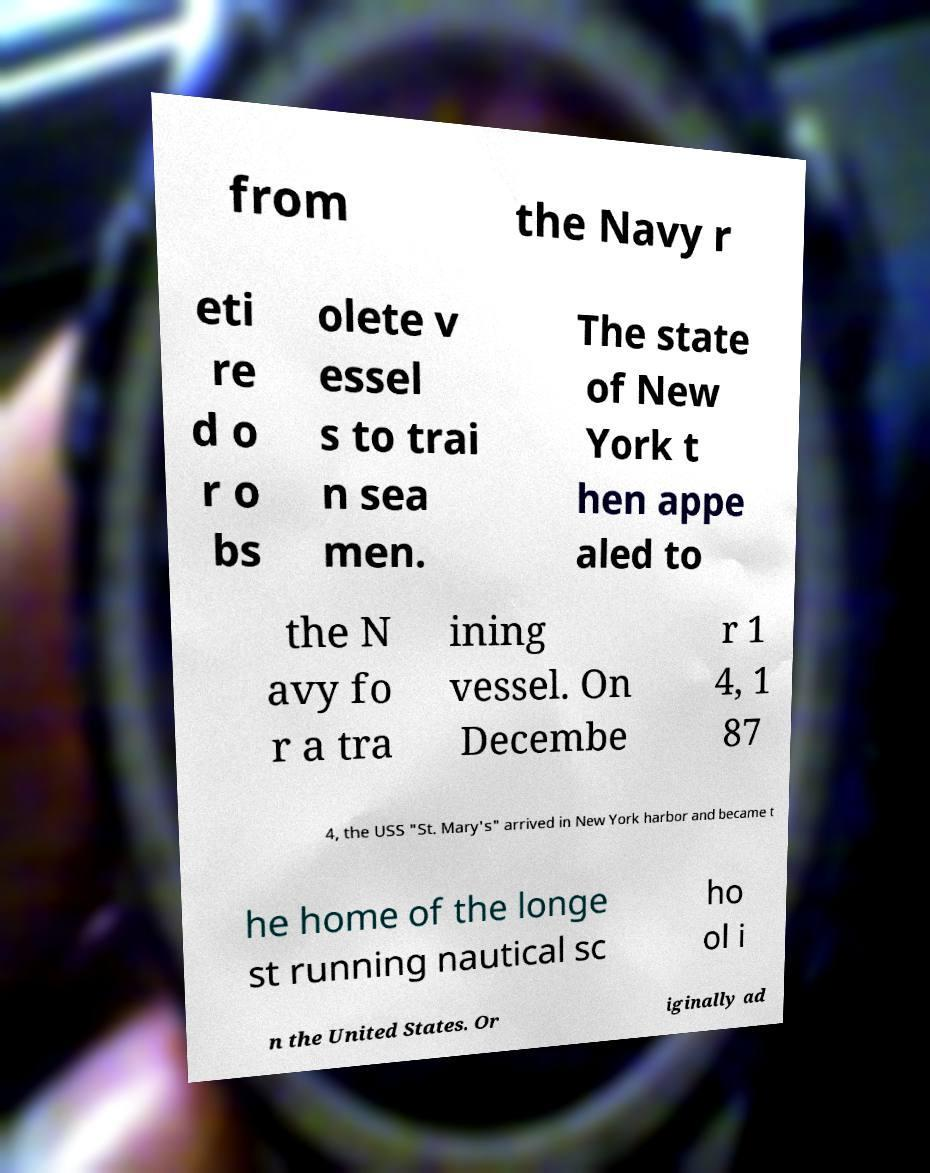Can you accurately transcribe the text from the provided image for me? from the Navy r eti re d o r o bs olete v essel s to trai n sea men. The state of New York t hen appe aled to the N avy fo r a tra ining vessel. On Decembe r 1 4, 1 87 4, the USS "St. Mary's" arrived in New York harbor and became t he home of the longe st running nautical sc ho ol i n the United States. Or iginally ad 